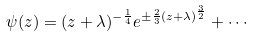Convert formula to latex. <formula><loc_0><loc_0><loc_500><loc_500>\psi ( z ) = ( z + \lambda ) ^ { - \frac { 1 } { 4 } } e ^ { \pm \frac { 2 } { 3 } ( z + \lambda ) ^ { \frac { 3 } { 2 } } } + \cdots \label l { e q \colon a i r y }</formula> 